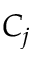Convert formula to latex. <formula><loc_0><loc_0><loc_500><loc_500>C _ { j }</formula> 